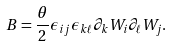Convert formula to latex. <formula><loc_0><loc_0><loc_500><loc_500>B = \frac { \theta } { 2 } \epsilon _ { i j } \epsilon _ { k \ell } \partial _ { k } W _ { i } \partial _ { \ell } W _ { j } .</formula> 